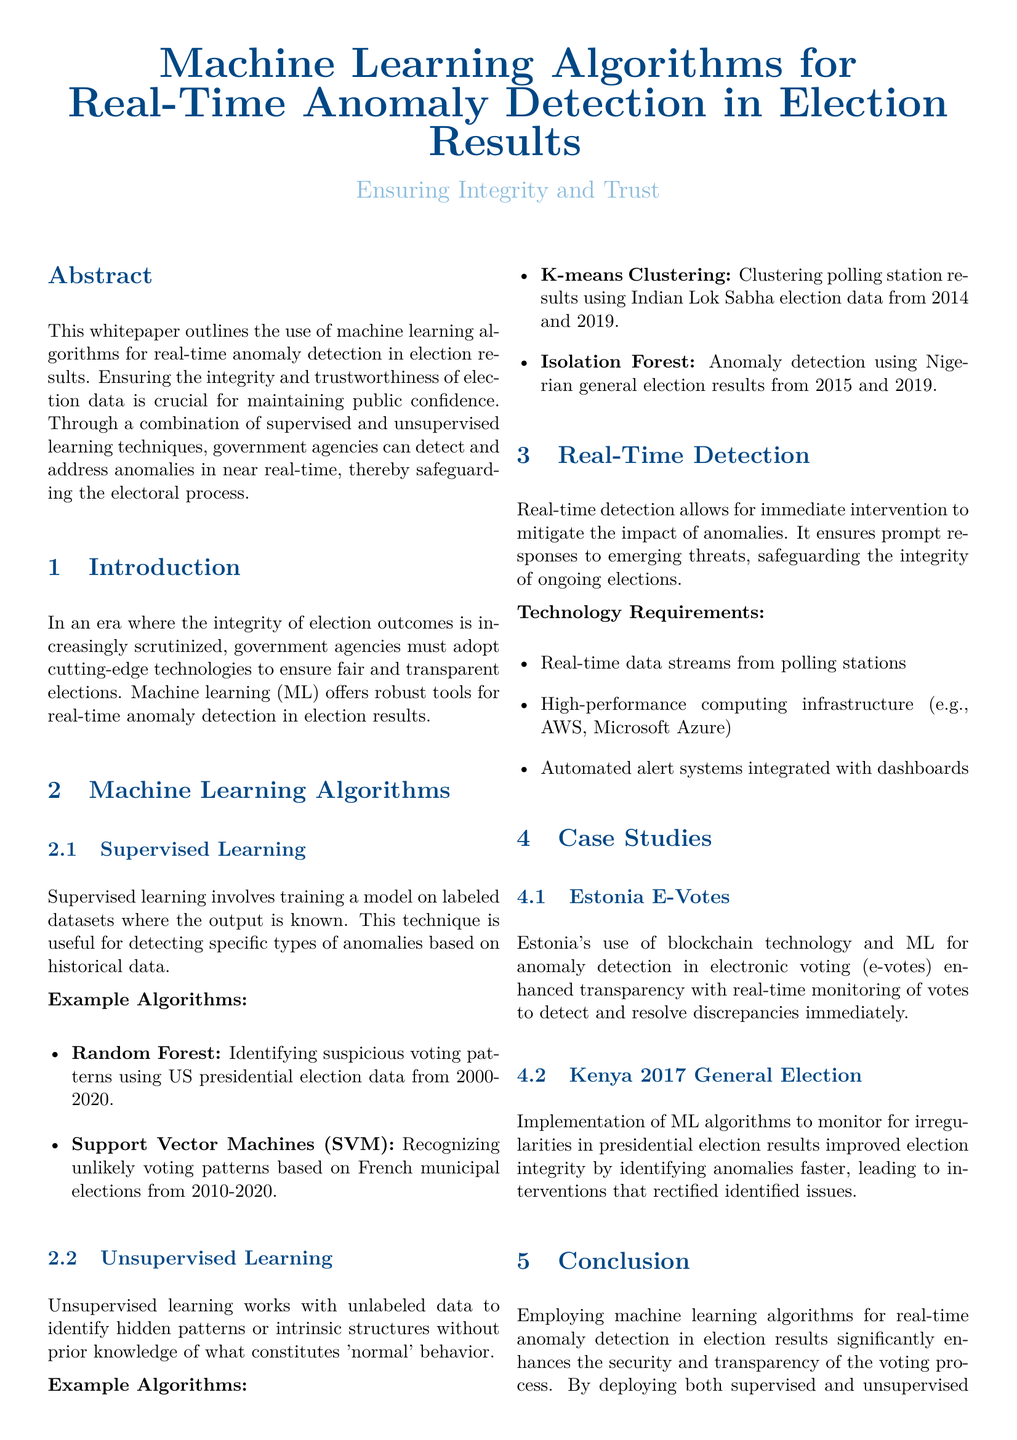What is the main focus of the whitepaper? The whitepaper centers on the use of machine learning algorithms for detecting anomalies in election results to ensure integrity and trust.
Answer: anomaly detection in election results What type of machine learning involves training on labeled datasets? This question relates to the section discussing different machine learning techniques in the document.
Answer: Supervised Learning What example algorithm is used for identifying suspicious voting patterns? The document provides specific examples of algorithms used for various purposes in election anomaly detection.
Answer: Random Forest Which country implemented machine learning algorithms to monitor the 2017 general election? This is specified in the case studies section regarding specific implementations of machine learning.
Answer: Kenya What technology is required for real-time detection? The document lists specific technology requirements crucial for the implementation of real-time anomaly detection in elections.
Answer: Real-time data streams from polling stations Which algorithm is mentioned for clustering polling station results? This question asks for information from the unsupervised learning section of the document.
Answer: K-means Clustering How does real-time anomaly detection impact public confidence? This question requires an understanding of the implications discussed in the conclusion of the document.
Answer: It bolsters public confidence What is the call to action mentioned in the whitepaper? This question refers to the concluding remarks which include a call to action tailored for government agencies.
Answer: Invest in and deploy ML-driven solutions for anomaly detection 